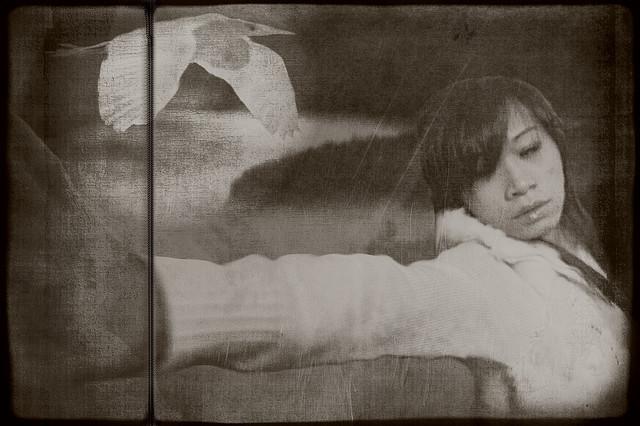What is the emotion on the girls face?
Write a very short answer. Sad. Is the photo grainy?
Keep it brief. Yes. What is flying?
Keep it brief. Bird. 